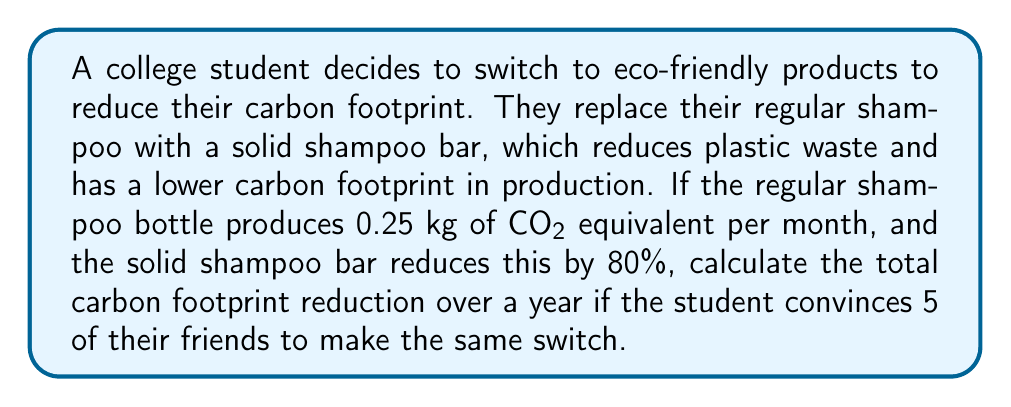Teach me how to tackle this problem. Let's break this problem down into steps:

1. Calculate the monthly carbon footprint reduction for one person:
   * Regular shampoo bottle footprint: 0.25 kg CO₂e/month
   * Reduction percentage: 80% = 0.80
   * Monthly reduction: $0.25 \times 0.80 = 0.20$ kg CO₂e/month

2. Calculate the annual carbon footprint reduction for one person:
   * Annual reduction = Monthly reduction $\times$ 12 months
   * $0.20 \times 12 = 2.40$ kg CO₂e/year

3. Calculate the total reduction for the student and their 5 friends:
   * Total people making the switch = 1 (student) + 5 (friends) = 6
   * Total annual reduction = Annual reduction per person $\times$ Number of people
   * $2.40 \times 6 = 14.40$ kg CO₂e/year

Therefore, the total carbon footprint reduction over a year for the student and their 5 friends is 14.40 kg CO₂e.
Answer: 14.40 kg CO₂e/year 